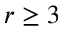<formula> <loc_0><loc_0><loc_500><loc_500>r \geq 3</formula> 